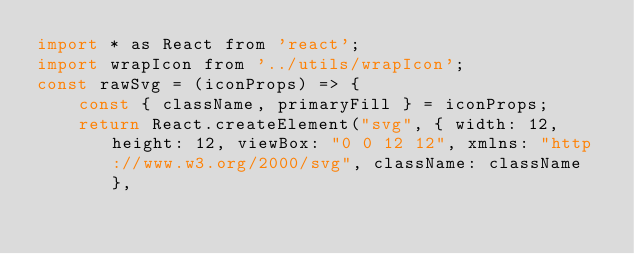<code> <loc_0><loc_0><loc_500><loc_500><_JavaScript_>import * as React from 'react';
import wrapIcon from '../utils/wrapIcon';
const rawSvg = (iconProps) => {
    const { className, primaryFill } = iconProps;
    return React.createElement("svg", { width: 12, height: 12, viewBox: "0 0 12 12", xmlns: "http://www.w3.org/2000/svg", className: className },</code> 